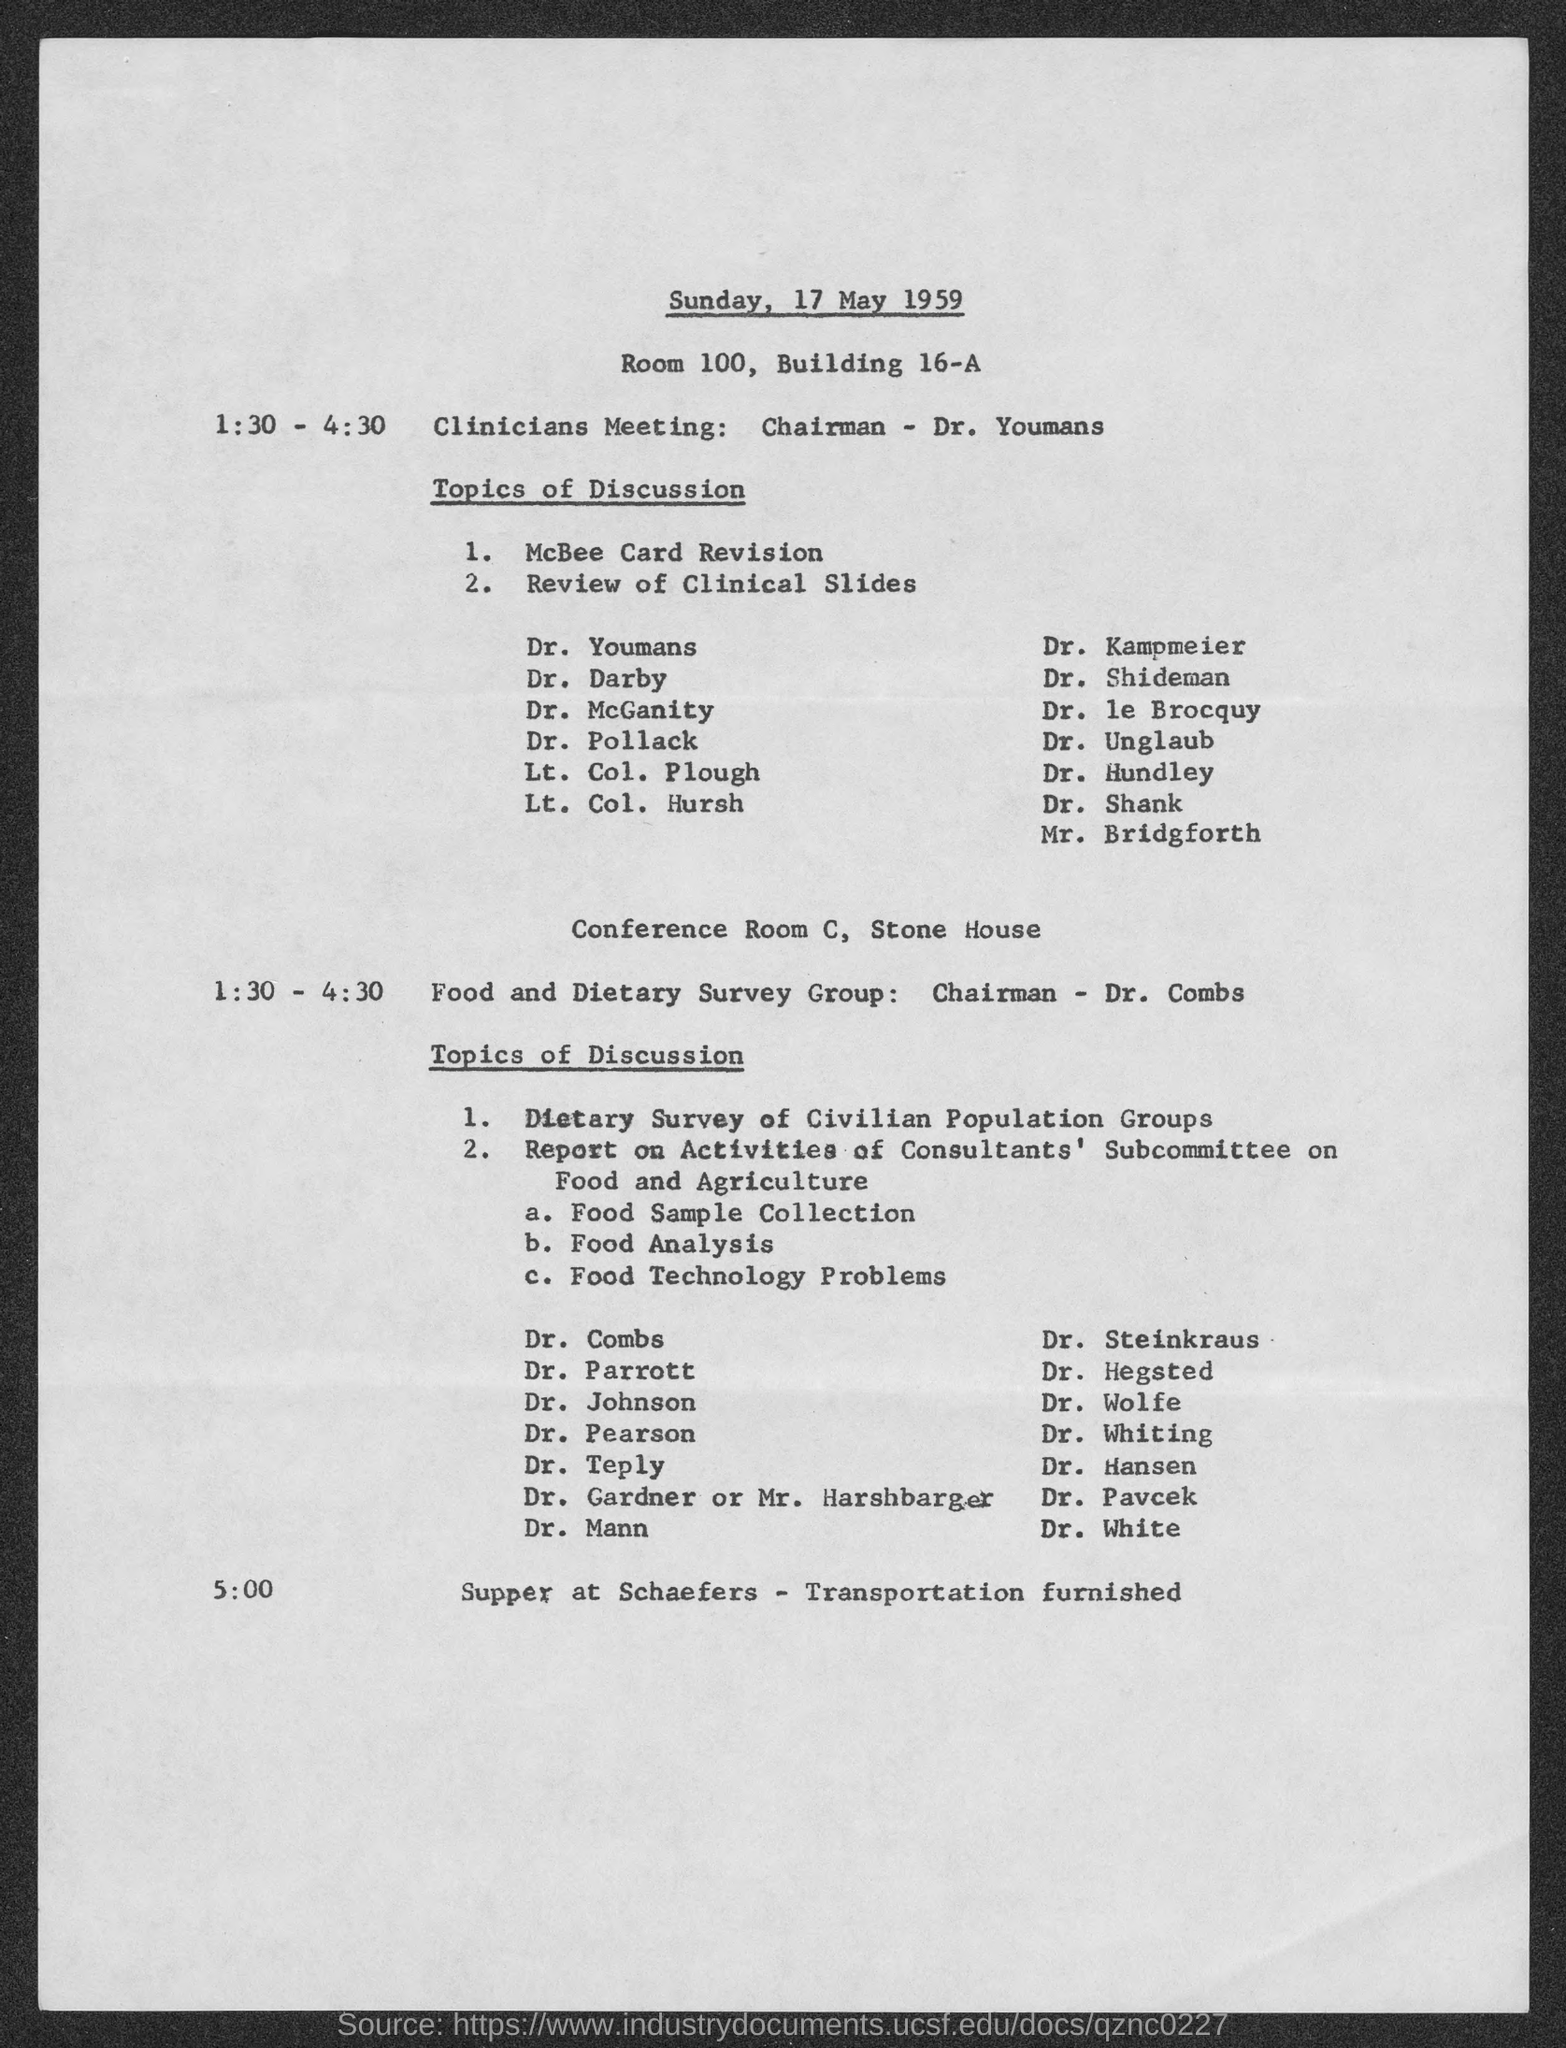Specify some key components in this picture. The meeting will take place on Sunday, May 17th, 1959. The time of the Food and Dietary Survey Group is from 1:30 PM to 4:30 PM. The time of the clinicians' meeting is from 1:30 PM to 4:30 PM. 